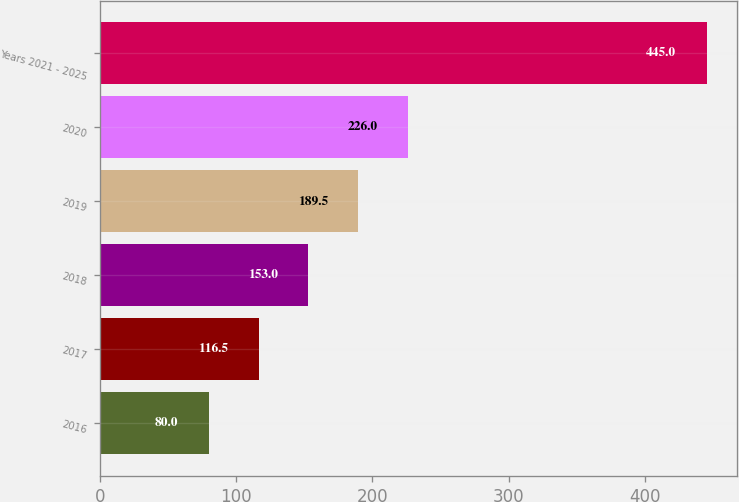<chart> <loc_0><loc_0><loc_500><loc_500><bar_chart><fcel>2016<fcel>2017<fcel>2018<fcel>2019<fcel>2020<fcel>Years 2021 - 2025<nl><fcel>80<fcel>116.5<fcel>153<fcel>189.5<fcel>226<fcel>445<nl></chart> 